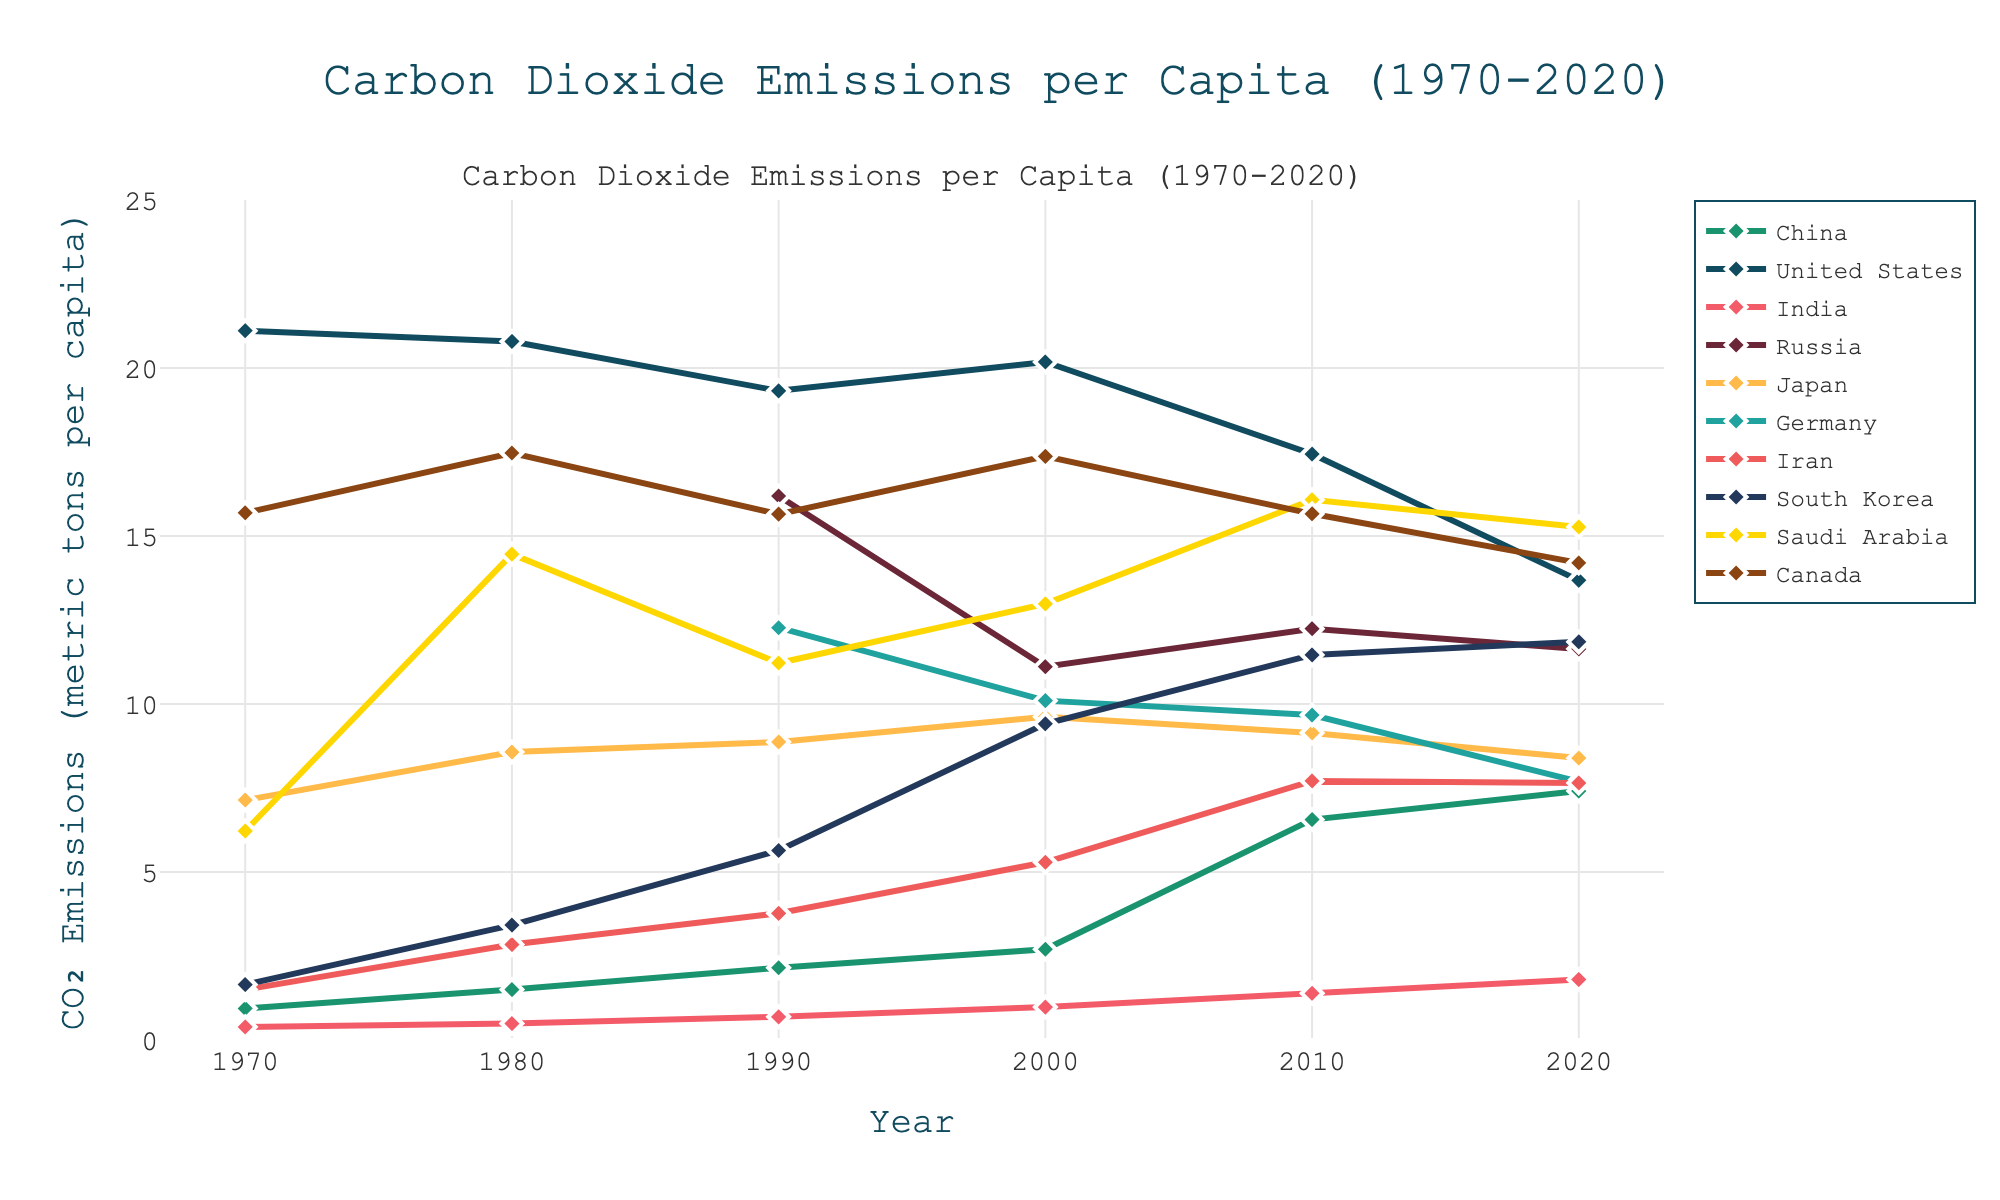Which country had the highest CO₂ emissions per capita in 2020? Look for the country with the highest endpoint on the 2020 axis. Saudi Arabia has the highest value in 2020.
Answer: Saudi Arabia Which country saw the largest increase in CO₂ emissions per capita from 1970 to 2020? Subtract the 1970 value from the 2020 value for each country. China had the most significant increase, from 0.94 to 7.41.
Answer: China Which country had a higher CO₂ emissions per capita in 1990: Canada or Germany? Compare the 1990 values for both countries. Canada's value is 15.65, and Germany’s is 12.27.
Answer: Canada What was the approximate CO₂ emissions per capita for the United States in 2010? Refer to the United States line at the year 2010. The value is around 17.44.
Answer: 17.44 By how much did India's CO₂ emissions per capita increase from 1970 to 2020? Subtract the 1970 value from the 2020 value for India. The values are 1.80 - 0.39.
Answer: 1.41 Which country had stable or decreasing CO₂ emissions per capita from 2010 to 2020? Identify the countries maintaining or reducing values between 2010 and 2020. The United States shows a decrease from 17.44 to 13.68.
Answer: United States How did South Korea’s CO₂ emissions per capita change from 1980 to 2000? Find the 1980 and 2000 values for South Korea and subtract the former from the latter. Values are 9.41 - 3.42.
Answer: 5.99 Compare the CO₂ emissions per capita of Saudi Arabia and Japan in 1980. Look at the 1980 values for both countries. Saudi Arabia's is 14.46, and Japan's is 8.57.
Answer: Saudi Arabia What was the general trend of CO₂ emissions per capita in China from 1970 to 2020? Observe the line for China. It shows a rising trend from 0.94 in 1970 to 7.41 in 2020.
Answer: Increasing In 2010, which two countries had very similar CO₂ emissions per capita? Compare the values for 2010. Iran (7.71) and China (6.56) are close but, Iran and South Korea are closer with Iran 7.71 and Korea 11.46, considerable similarity.
Answer: Iran and South Korea 